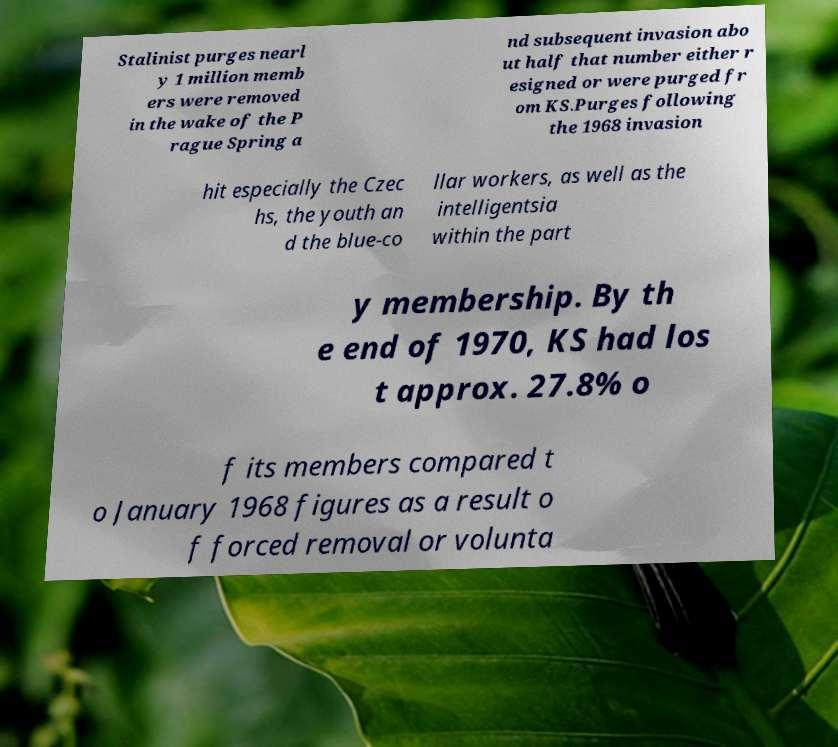Could you assist in decoding the text presented in this image and type it out clearly? Stalinist purges nearl y 1 million memb ers were removed in the wake of the P rague Spring a nd subsequent invasion abo ut half that number either r esigned or were purged fr om KS.Purges following the 1968 invasion hit especially the Czec hs, the youth an d the blue-co llar workers, as well as the intelligentsia within the part y membership. By th e end of 1970, KS had los t approx. 27.8% o f its members compared t o January 1968 figures as a result o f forced removal or volunta 